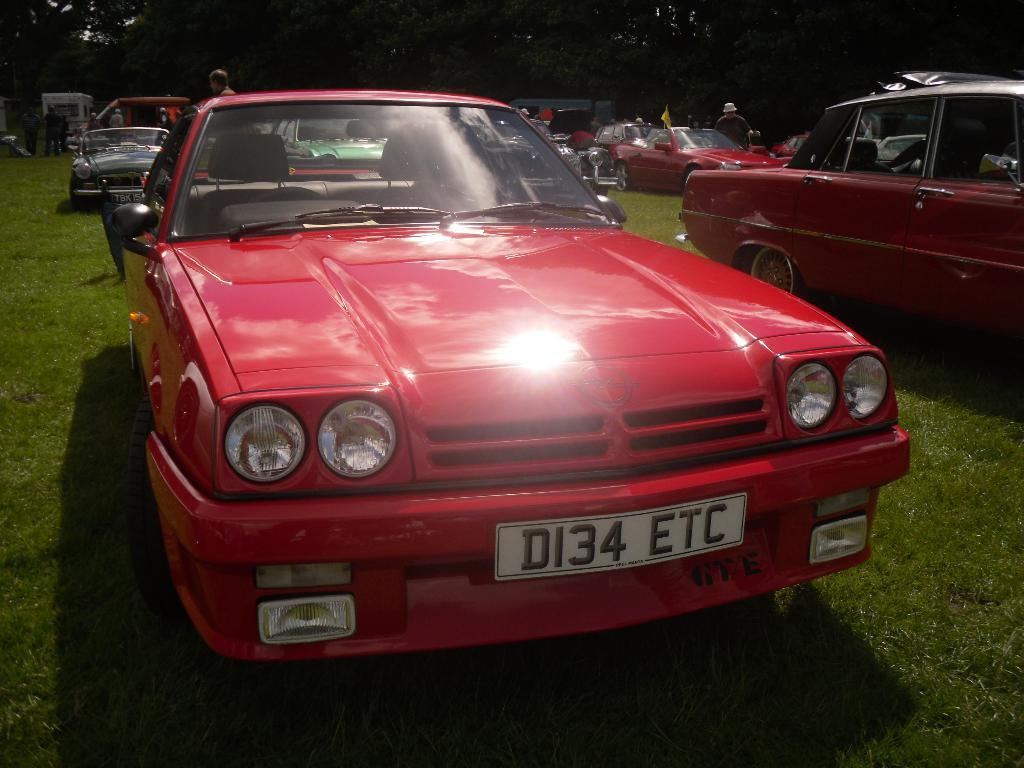What can be seen parked in the image? There are cars parked in the image. What else is visible in the image besides the parked cars? There are people standing in the image, and some cars are red in color. Can you describe the appearance of one of the people in the image? There is a man wearing a hat in the image. What type of vegetation is visible in the image? Trees are visible in the image. What is the ground surface like in the image? Grass is present on the ground in the image. What is the man doing with his tongue in the image? There is no indication in the image that the man is doing anything with his tongue. Why are the people in the image crying? There is no indication in the image that the people are crying. 